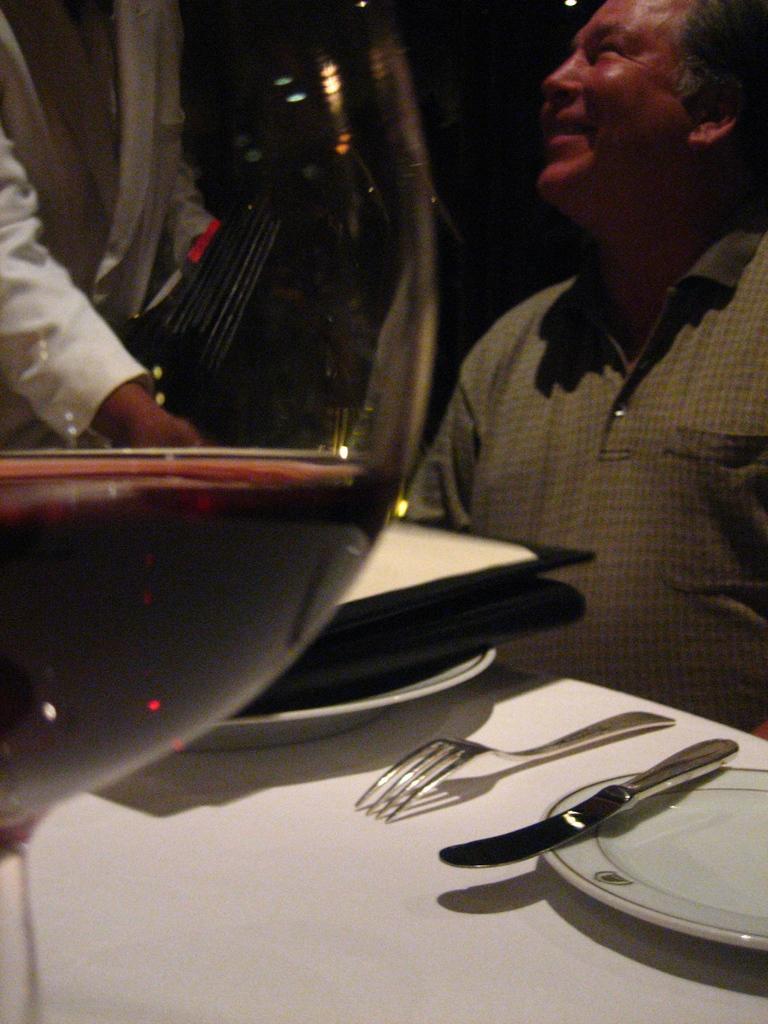Can you describe this image briefly? This image consists of a wine glass. To the right, there is a person sitting. In the front, there is a table on which there are plates and spoons kept. 